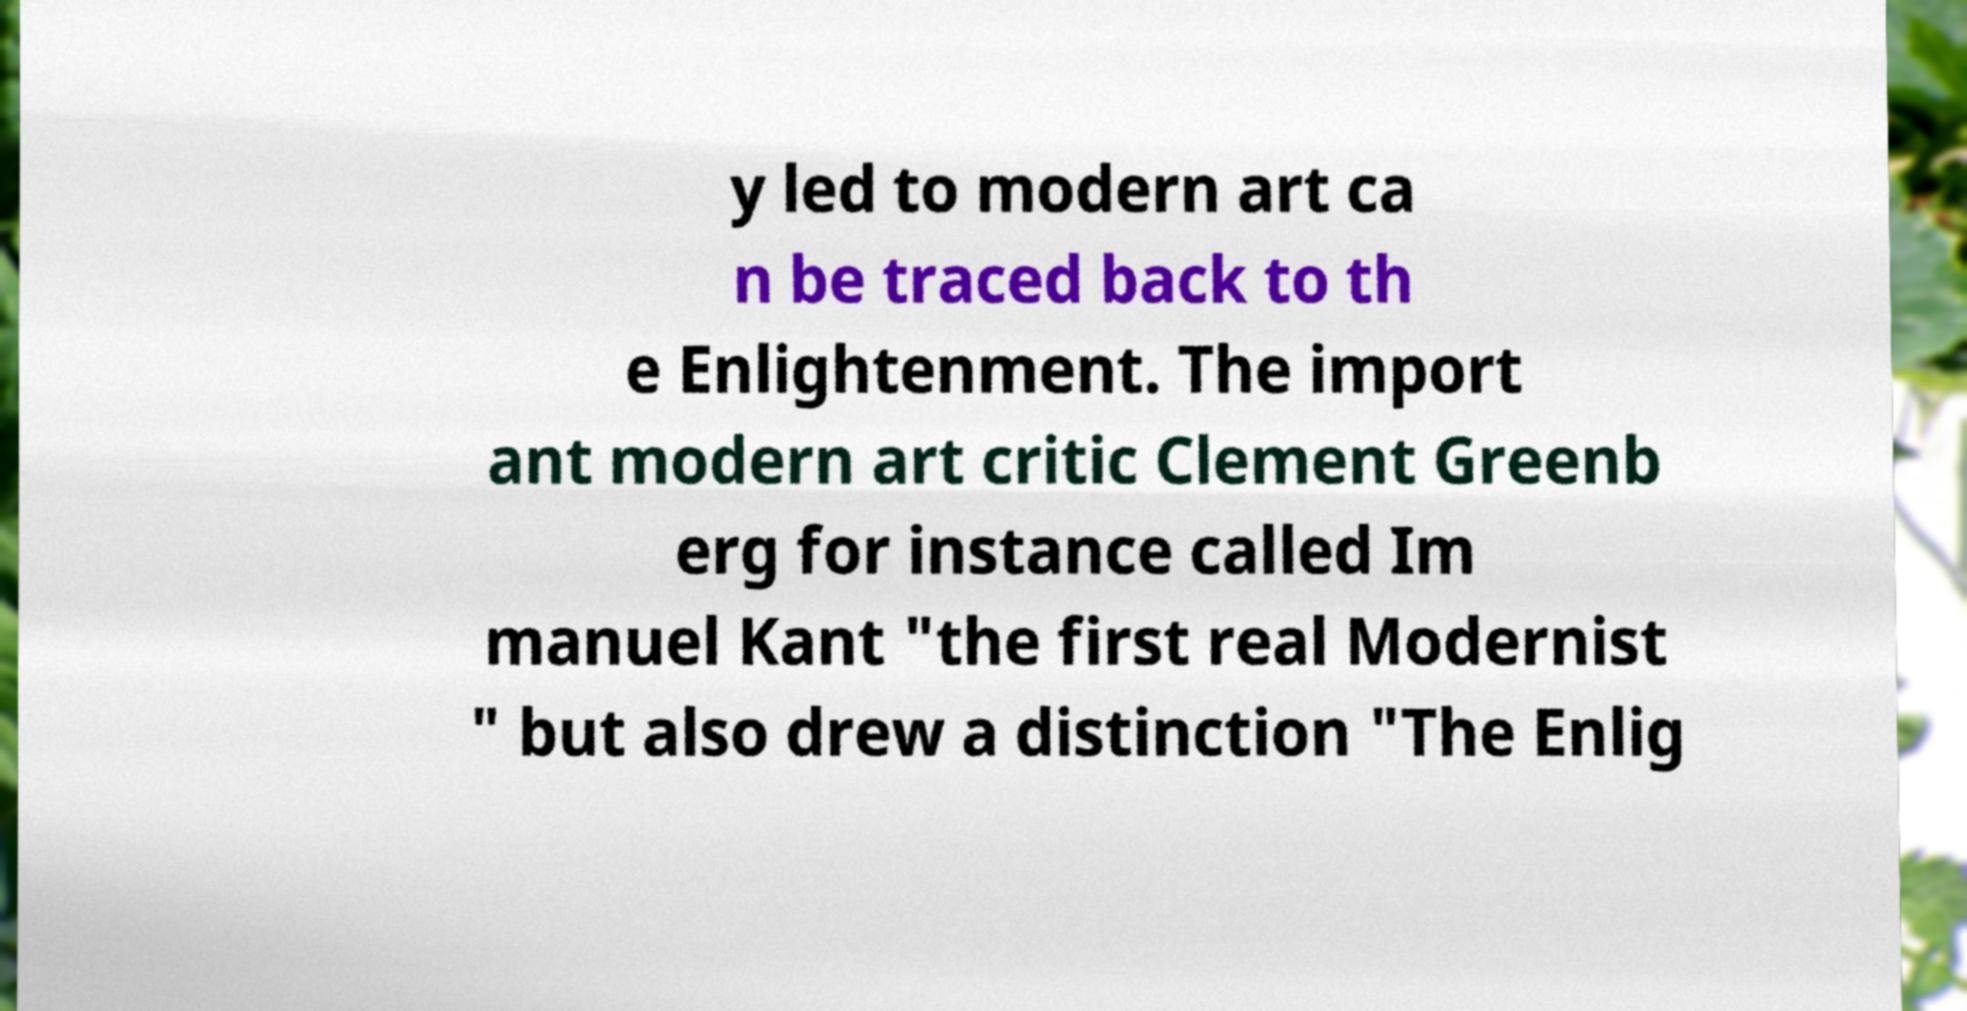What messages or text are displayed in this image? I need them in a readable, typed format. y led to modern art ca n be traced back to th e Enlightenment. The import ant modern art critic Clement Greenb erg for instance called Im manuel Kant "the first real Modernist " but also drew a distinction "The Enlig 